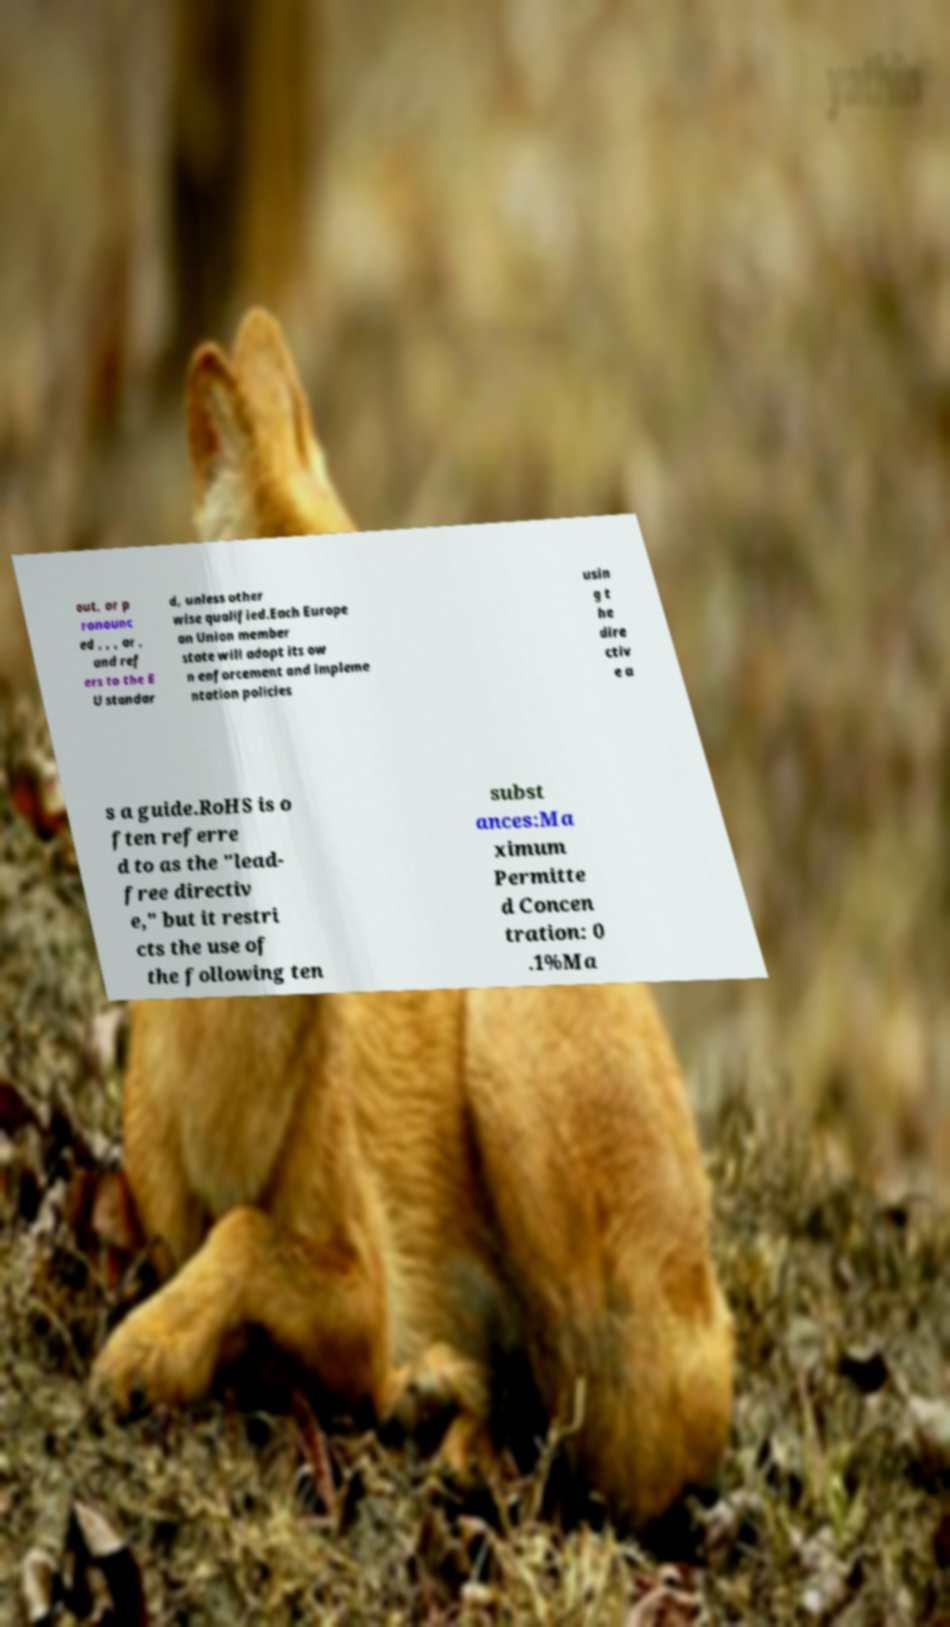Could you assist in decoding the text presented in this image and type it out clearly? out, or p ronounc ed , , , or , and ref ers to the E U standar d, unless other wise qualified.Each Europe an Union member state will adopt its ow n enforcement and impleme ntation policies usin g t he dire ctiv e a s a guide.RoHS is o ften referre d to as the "lead- free directiv e," but it restri cts the use of the following ten subst ances:Ma ximum Permitte d Concen tration: 0 .1%Ma 